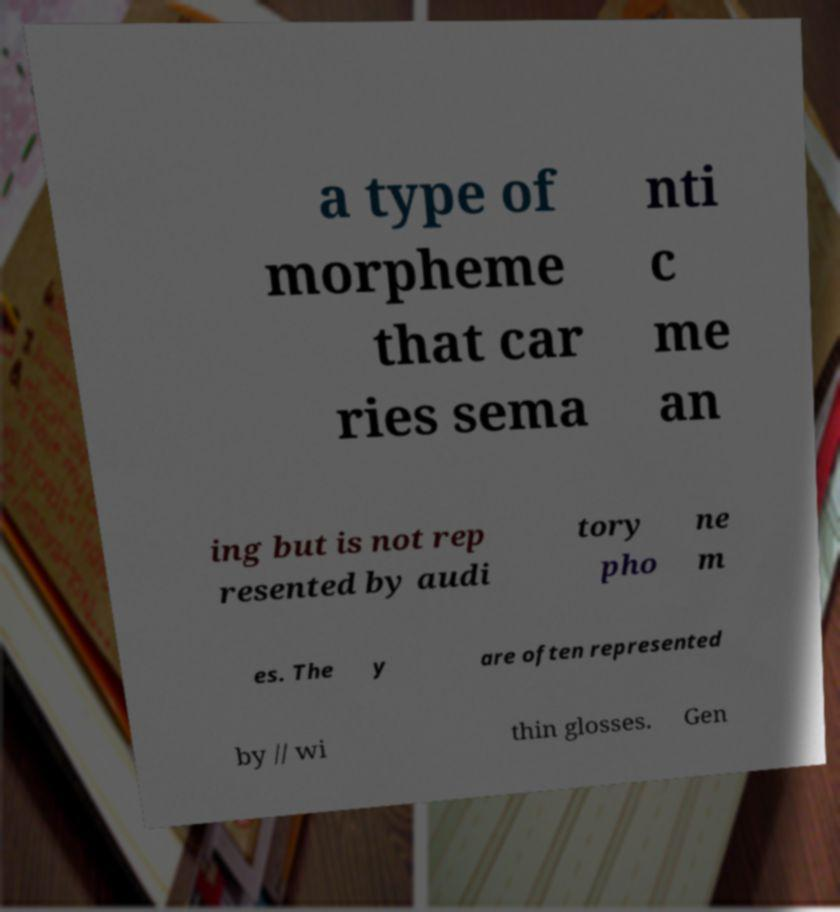Can you accurately transcribe the text from the provided image for me? a type of morpheme that car ries sema nti c me an ing but is not rep resented by audi tory pho ne m es. The y are often represented by // wi thin glosses. Gen 